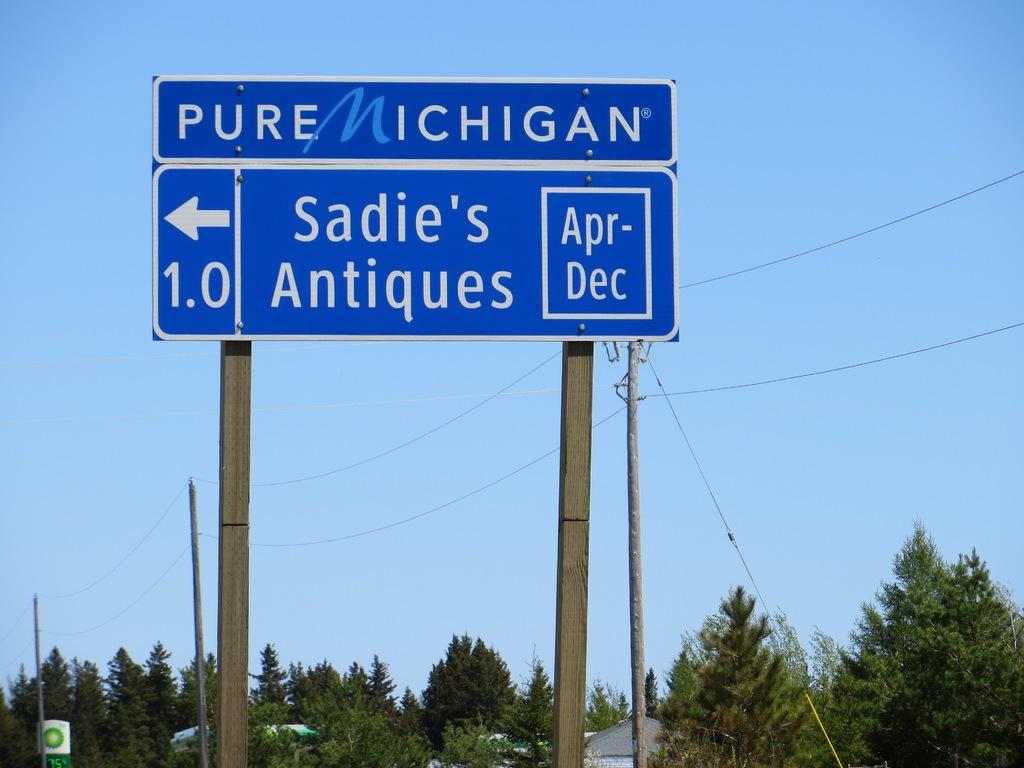<image>
Give a short and clear explanation of the subsequent image. A blue street sign reading PURE MICHIGAN, Sadie's Antiques Apr-Dec, with an arrow pointing left over a 1.0. 